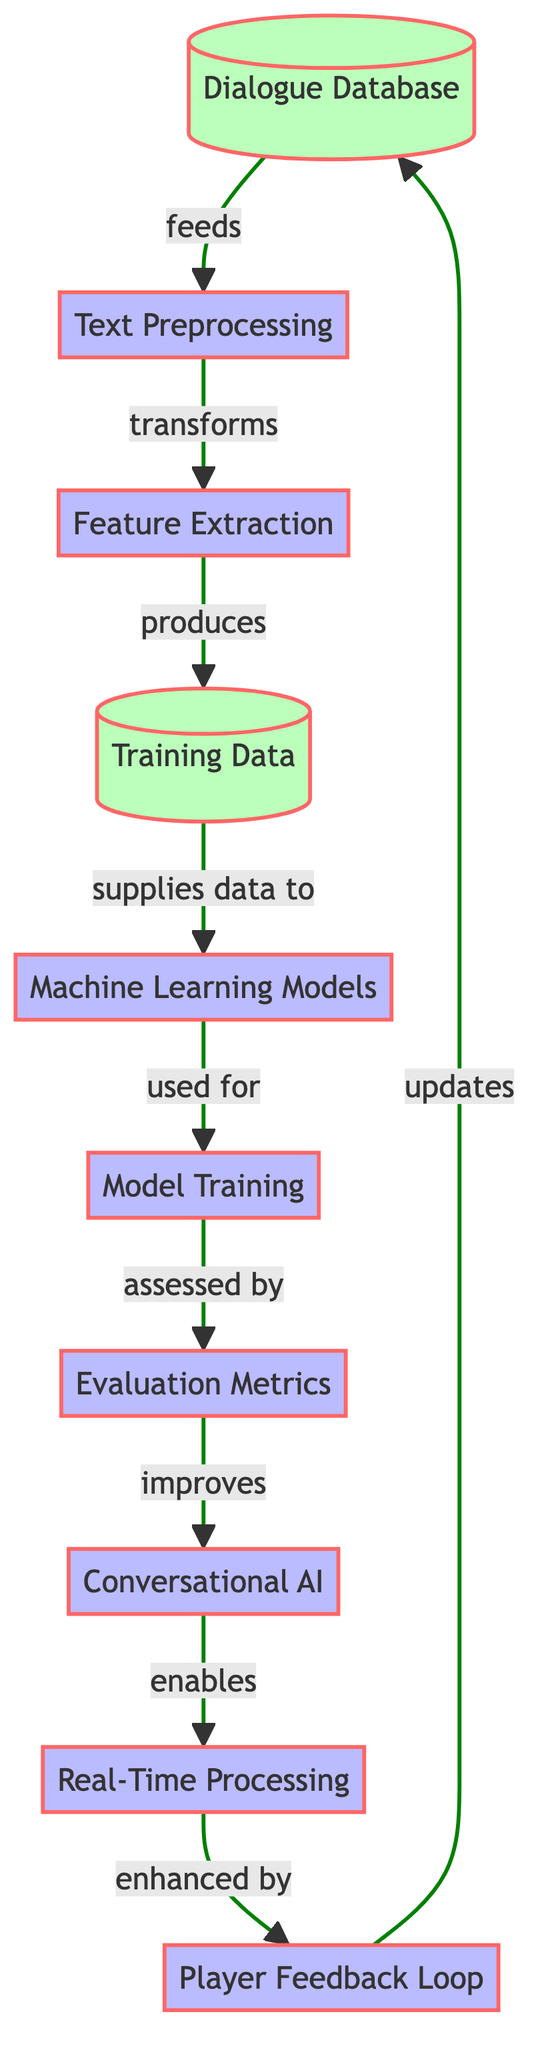What is the first node in the diagram? The first node is labeled "Dialogue Database." It is the starting point of the flowchart, which indicates the origin of data used in the process.
Answer: Dialogue Database How many process nodes are present in the diagram? The diagram has six process nodes, which include "Text Preprocessing," "Feature Extraction," "Machine Learning Models," "Model Training," "Evaluation Metrics," and "Conversational AI." Each process node signifies a step in the optimization workflow.
Answer: 6 What node follows "Feature Extraction"? The node that follows "Feature Extraction" is labeled "Training Data." This indicates that after features are extracted from the text, they are compiled into training data for the machine learning model.
Answer: Training Data Which node is enhanced by the "Player Feedback Loop"? The node enhanced by the "Player Feedback Loop" is the "Real-Time Processing" node. It suggests that feedback from players is used to improve how the conversational AI processes dialogue in real time.
Answer: Real-Time Processing What is the relationship between "Model Training" and "Evaluation Metrics"? The relationship is that "Model Training" is assessed by "Evaluation Metrics." This shows that the performance of the trained models is determined through various metrics that evaluate their effectiveness.
Answer: assessed by Which node produces the "Training Data"? The "Feature Extraction" node produces the "Training Data." It indicates that after preprocessing the text, features are extracted, and these features are then supplied as training data for the machine learning models.
Answer: Feature Extraction What does the "Conversational AI" enable? The "Conversational AI" enables "Real-Time Processing." This means that once the conversational AI is improved, it can then function in real-time to respond to player inputs during gameplay.
Answer: Real-Time Processing How does "Model Training" contribute to the "Conversational AI"? "Model Training" improves the "Conversational AI." This indicates that through the training processes applied to the models, their performance and capabilities in dialogue generation and interaction improve.
Answer: improves What feedback mechanism is used in this system? The feedback mechanism used is the "Player Feedback Loop," which collects input from players to continually refine and optimize the dialogue system and enhance the AI's conversational abilities.
Answer: Player Feedback Loop 